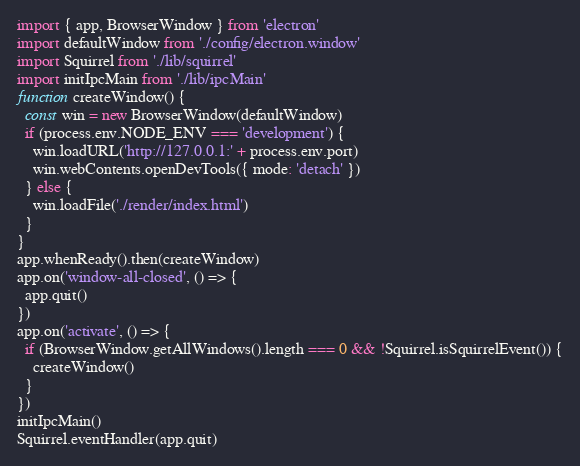Convert code to text. <code><loc_0><loc_0><loc_500><loc_500><_TypeScript_>import { app, BrowserWindow } from 'electron'
import defaultWindow from './config/electron.window'
import Squirrel from './lib/squirrel'
import initIpcMain from './lib/ipcMain'
function createWindow() {
  const win = new BrowserWindow(defaultWindow)
  if (process.env.NODE_ENV === 'development') {
    win.loadURL('http://127.0.0.1:' + process.env.port)
    win.webContents.openDevTools({ mode: 'detach' })
  } else {
    win.loadFile('./render/index.html')
  }
}
app.whenReady().then(createWindow)
app.on('window-all-closed', () => {
  app.quit()
})
app.on('activate', () => {
  if (BrowserWindow.getAllWindows().length === 0 && !Squirrel.isSquirrelEvent()) {
    createWindow()
  }
})
initIpcMain()
Squirrel.eventHandler(app.quit)
</code> 